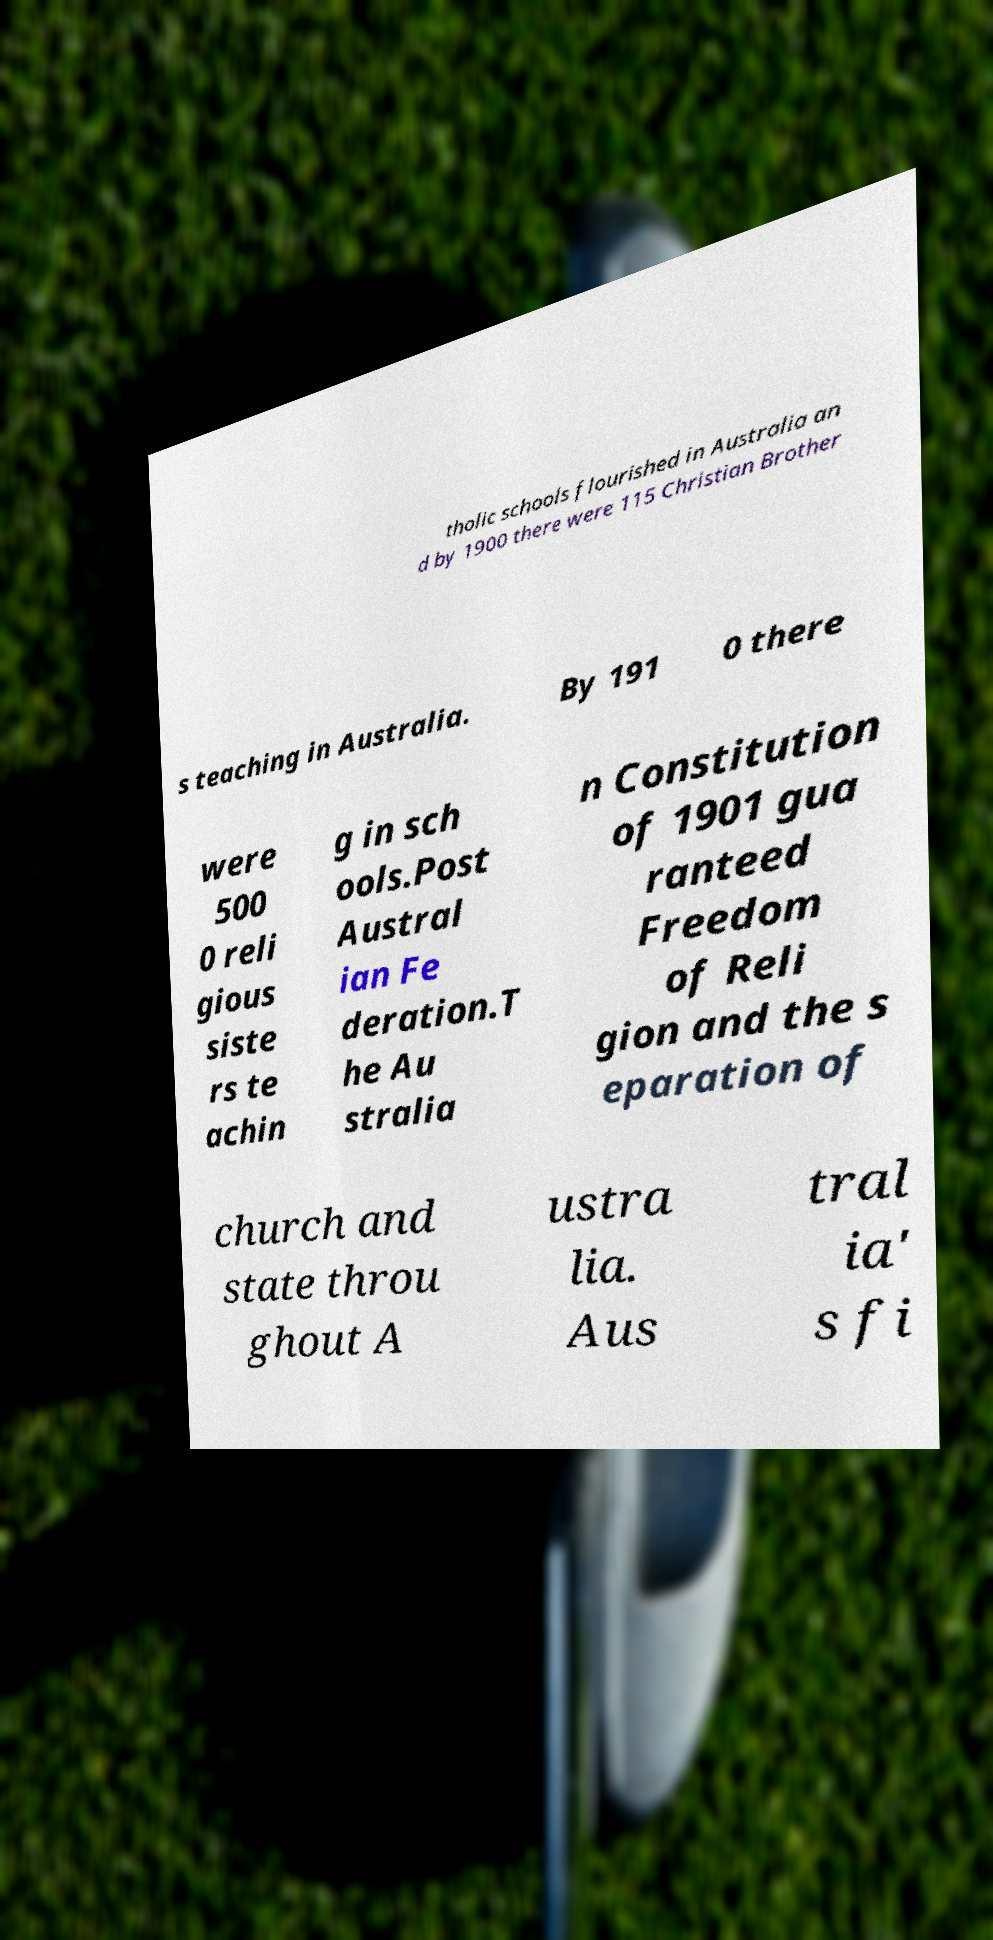Please read and relay the text visible in this image. What does it say? tholic schools flourished in Australia an d by 1900 there were 115 Christian Brother s teaching in Australia. By 191 0 there were 500 0 reli gious siste rs te achin g in sch ools.Post Austral ian Fe deration.T he Au stralia n Constitution of 1901 gua ranteed Freedom of Reli gion and the s eparation of church and state throu ghout A ustra lia. Aus tral ia' s fi 